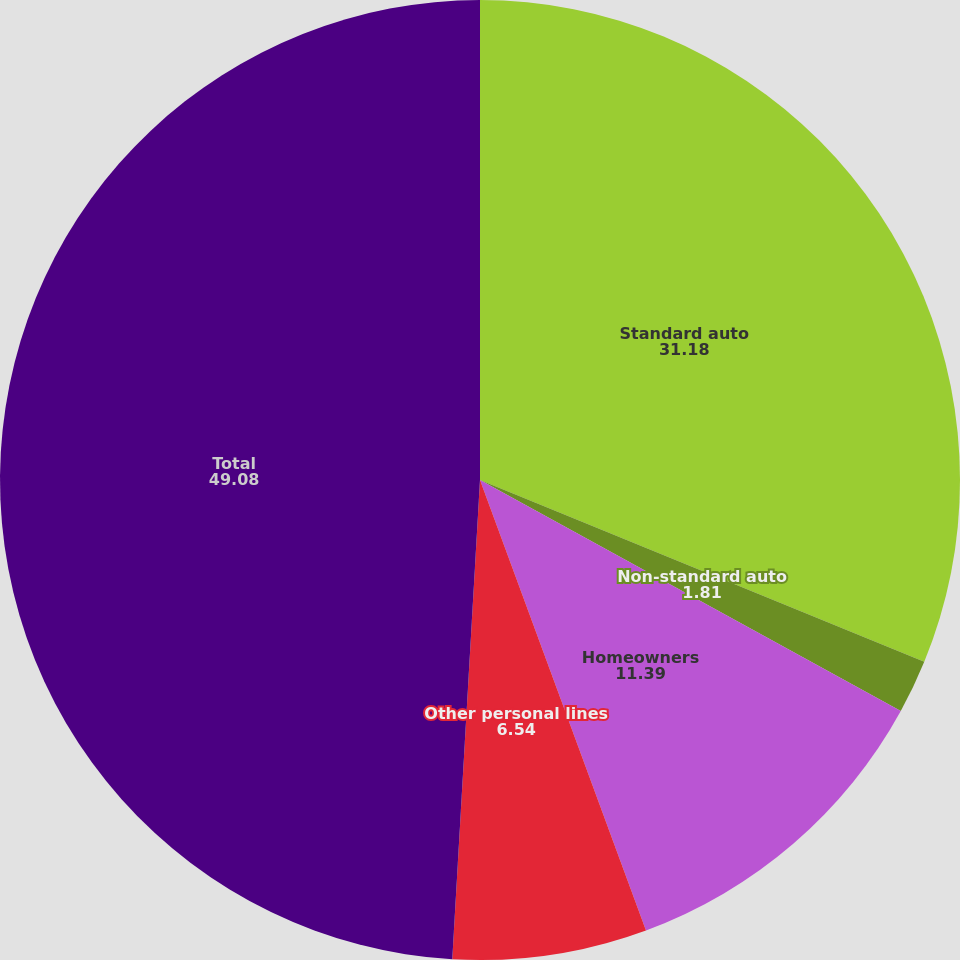Convert chart. <chart><loc_0><loc_0><loc_500><loc_500><pie_chart><fcel>Standard auto<fcel>Non-standard auto<fcel>Homeowners<fcel>Other personal lines<fcel>Total<nl><fcel>31.18%<fcel>1.81%<fcel>11.39%<fcel>6.54%<fcel>49.08%<nl></chart> 